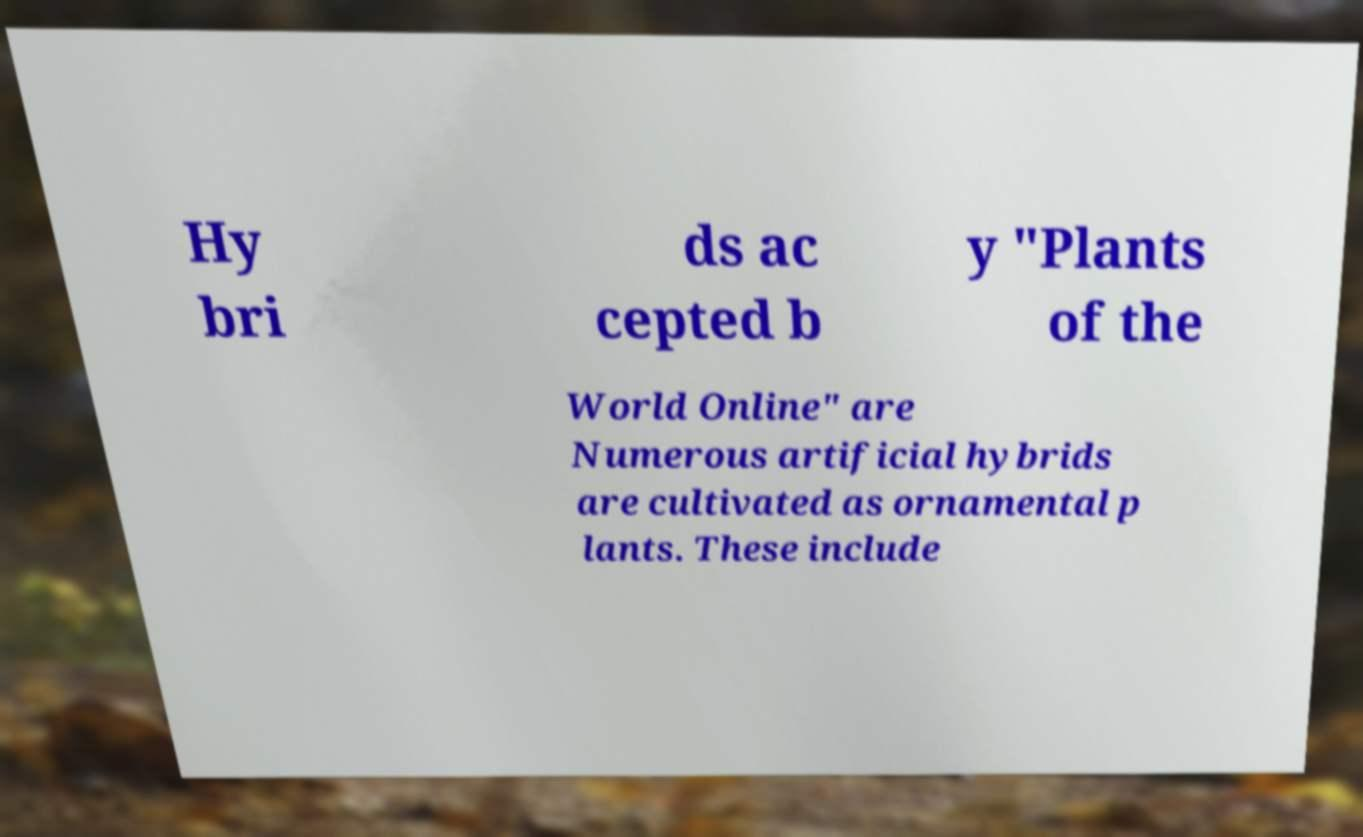What messages or text are displayed in this image? I need them in a readable, typed format. Hy bri ds ac cepted b y "Plants of the World Online" are Numerous artificial hybrids are cultivated as ornamental p lants. These include 